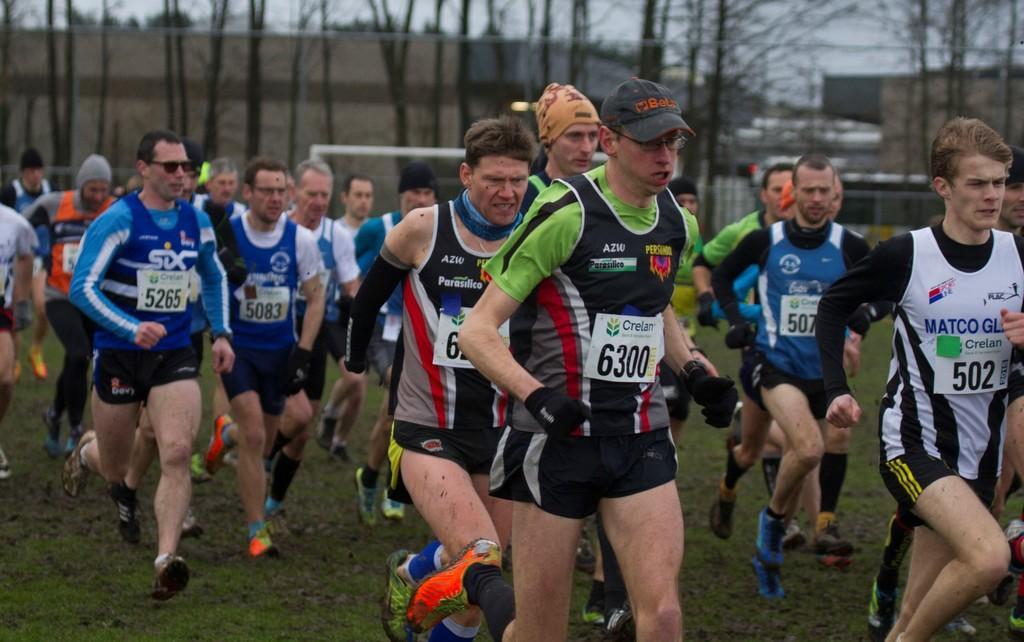How would you summarize this image in a sentence or two? In this image we can see group of people wearing dress are walking on the ground. One person wearing green t shirt with cap and spectacles is wearing gloves on his hands. In the background ,we can see a goal post and group of trees and sky. 